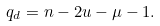Convert formula to latex. <formula><loc_0><loc_0><loc_500><loc_500>q _ { d } = n - 2 u - \mu - 1 .</formula> 